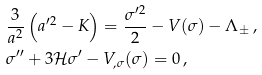<formula> <loc_0><loc_0><loc_500><loc_500>& \frac { 3 } { a ^ { 2 } } \left ( a ^ { \prime 2 } - K \right ) = \frac { \sigma ^ { \prime 2 } } { 2 } - V ( \sigma ) - \Lambda _ { \pm } \, , \\ & \sigma ^ { \prime \prime } + 3 \mathcal { H } \sigma ^ { \prime } - V _ { , \sigma } ( \sigma ) = 0 \, ,</formula> 